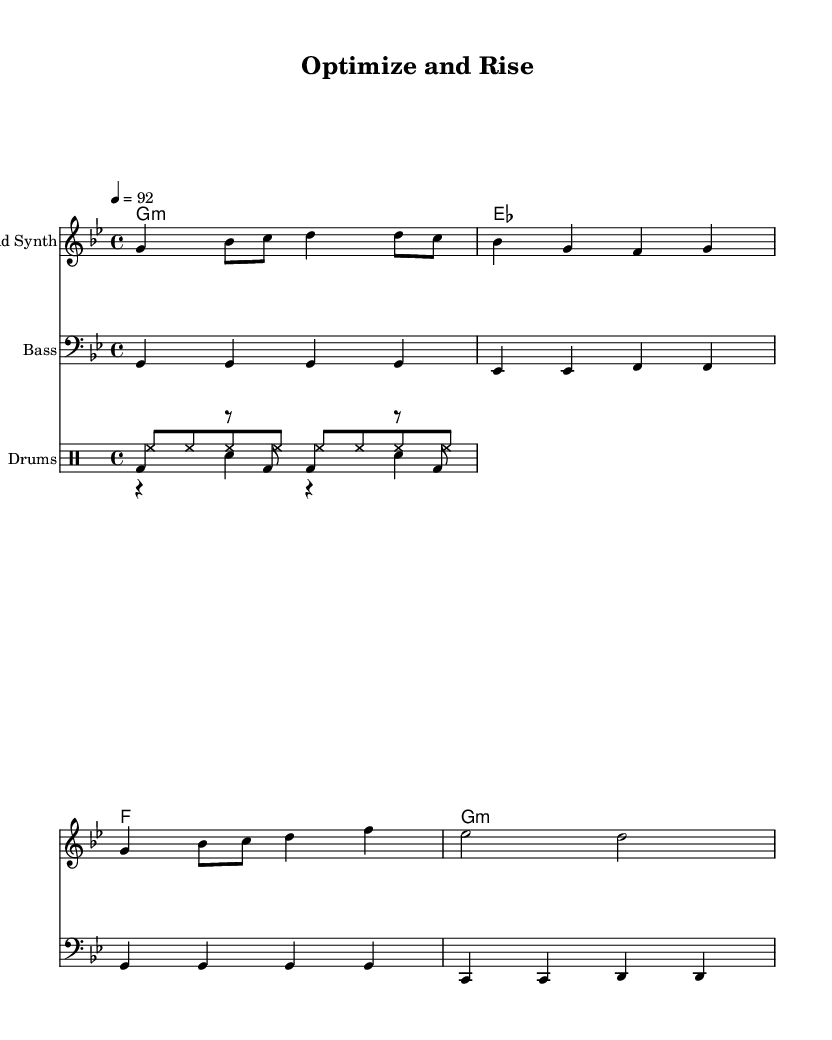What is the key signature of this music? The key signature is G minor, which has two flats (B flat and E flat). This can be confirmed by looking at the beginning of the staff where the flats are indicated.
Answer: G minor What is the time signature? The time signature is 4/4, meaning there are four beats in each measure and the quarter note gets one beat. This is indicated near the beginning of the score, showing a "4" over another "4".
Answer: 4/4 What is the tempo marking for this piece? The tempo marking is 92 beats per minute, specified in the tempo directive at the top of the score. This provides the performers with the speed at which to play the music.
Answer: 92 How many beats are in the first measure of the lead synth? The first measure consists of four beats in total - this can be deduced by counting the note values in the measure (1 quarter note, 1 eighth note, 1 quarter note, 1 eighth note, and 1 quarter note equals four beats).
Answer: 4 Which instruments are present in this score? The instruments present in this score are Lead Synth, Bass, and Drums. Each section in the score is labeled with the corresponding instrument name, indicating their individual parts for the performance.
Answer: Lead Synth, Bass, Drums What lyric line describes optimizing the code? The lyric line that describes optimizing the code is "Op -- ti -- mize the code, watch the per -- for -- mance soar". This is evident from the lyrics section below the musical notation for the lead synth.
Answer: Op -- ti -- mize the code What is the chord progression indicated in the score? The chord progression follows a G minor, E flat, F, G minor sequence, which is shown in the chord names section above the staff. This gives insight into the harmonic structure of the piece.
Answer: G minor, E flat, F, G minor 